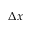<formula> <loc_0><loc_0><loc_500><loc_500>\Delta x</formula> 